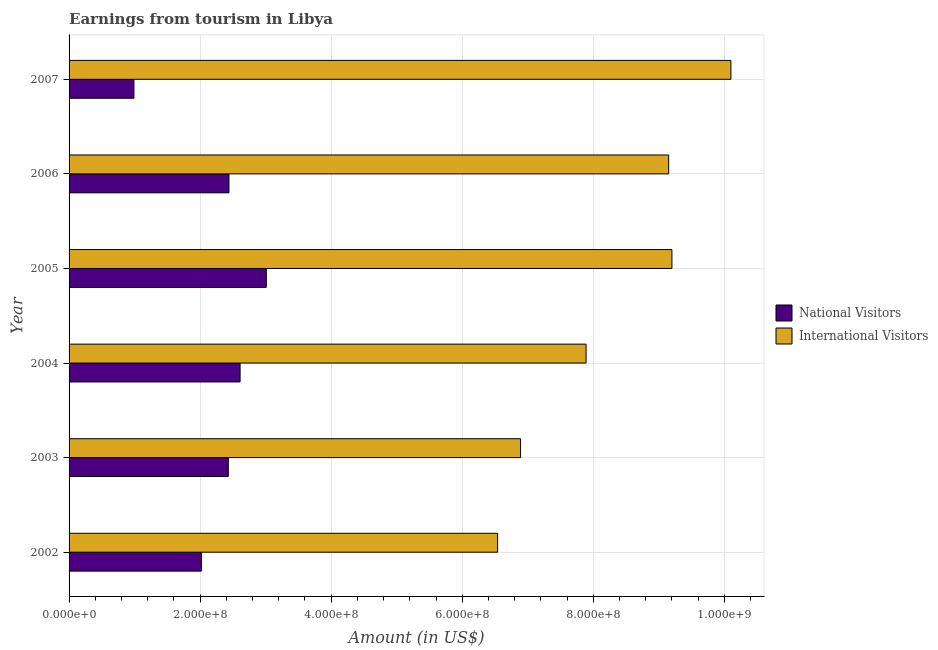How many different coloured bars are there?
Keep it short and to the point. 2. How many groups of bars are there?
Offer a terse response. 6. Are the number of bars on each tick of the Y-axis equal?
Your answer should be very brief. Yes. How many bars are there on the 3rd tick from the top?
Provide a short and direct response. 2. In how many cases, is the number of bars for a given year not equal to the number of legend labels?
Give a very brief answer. 0. What is the amount earned from international visitors in 2005?
Offer a very short reply. 9.20e+08. Across all years, what is the maximum amount earned from national visitors?
Your answer should be compact. 3.01e+08. Across all years, what is the minimum amount earned from national visitors?
Your answer should be very brief. 9.90e+07. In which year was the amount earned from international visitors maximum?
Keep it short and to the point. 2007. What is the total amount earned from international visitors in the graph?
Offer a terse response. 4.98e+09. What is the difference between the amount earned from international visitors in 2002 and that in 2007?
Make the answer very short. -3.56e+08. What is the difference between the amount earned from national visitors in 2004 and the amount earned from international visitors in 2005?
Ensure brevity in your answer.  -6.59e+08. What is the average amount earned from international visitors per year?
Provide a succinct answer. 8.30e+08. In the year 2002, what is the difference between the amount earned from international visitors and amount earned from national visitors?
Give a very brief answer. 4.52e+08. What is the ratio of the amount earned from international visitors in 2003 to that in 2007?
Keep it short and to the point. 0.68. Is the amount earned from national visitors in 2004 less than that in 2005?
Ensure brevity in your answer.  Yes. What is the difference between the highest and the second highest amount earned from international visitors?
Offer a terse response. 9.00e+07. What is the difference between the highest and the lowest amount earned from national visitors?
Offer a very short reply. 2.02e+08. In how many years, is the amount earned from international visitors greater than the average amount earned from international visitors taken over all years?
Your response must be concise. 3. What does the 2nd bar from the top in 2006 represents?
Your answer should be compact. National Visitors. What does the 2nd bar from the bottom in 2005 represents?
Your answer should be compact. International Visitors. How many bars are there?
Offer a very short reply. 12. Does the graph contain any zero values?
Offer a very short reply. No. Does the graph contain grids?
Offer a terse response. Yes. How many legend labels are there?
Your answer should be very brief. 2. What is the title of the graph?
Ensure brevity in your answer.  Earnings from tourism in Libya. Does "Urban Population" appear as one of the legend labels in the graph?
Your answer should be very brief. No. What is the label or title of the X-axis?
Offer a terse response. Amount (in US$). What is the label or title of the Y-axis?
Provide a short and direct response. Year. What is the Amount (in US$) in National Visitors in 2002?
Provide a short and direct response. 2.02e+08. What is the Amount (in US$) in International Visitors in 2002?
Your response must be concise. 6.54e+08. What is the Amount (in US$) of National Visitors in 2003?
Provide a succinct answer. 2.43e+08. What is the Amount (in US$) in International Visitors in 2003?
Give a very brief answer. 6.89e+08. What is the Amount (in US$) of National Visitors in 2004?
Give a very brief answer. 2.61e+08. What is the Amount (in US$) in International Visitors in 2004?
Make the answer very short. 7.89e+08. What is the Amount (in US$) in National Visitors in 2005?
Keep it short and to the point. 3.01e+08. What is the Amount (in US$) of International Visitors in 2005?
Keep it short and to the point. 9.20e+08. What is the Amount (in US$) in National Visitors in 2006?
Make the answer very short. 2.44e+08. What is the Amount (in US$) in International Visitors in 2006?
Offer a terse response. 9.15e+08. What is the Amount (in US$) in National Visitors in 2007?
Your response must be concise. 9.90e+07. What is the Amount (in US$) in International Visitors in 2007?
Give a very brief answer. 1.01e+09. Across all years, what is the maximum Amount (in US$) in National Visitors?
Keep it short and to the point. 3.01e+08. Across all years, what is the maximum Amount (in US$) in International Visitors?
Your answer should be very brief. 1.01e+09. Across all years, what is the minimum Amount (in US$) of National Visitors?
Offer a terse response. 9.90e+07. Across all years, what is the minimum Amount (in US$) of International Visitors?
Make the answer very short. 6.54e+08. What is the total Amount (in US$) in National Visitors in the graph?
Provide a short and direct response. 1.35e+09. What is the total Amount (in US$) of International Visitors in the graph?
Make the answer very short. 4.98e+09. What is the difference between the Amount (in US$) in National Visitors in 2002 and that in 2003?
Keep it short and to the point. -4.10e+07. What is the difference between the Amount (in US$) of International Visitors in 2002 and that in 2003?
Offer a terse response. -3.50e+07. What is the difference between the Amount (in US$) in National Visitors in 2002 and that in 2004?
Offer a very short reply. -5.90e+07. What is the difference between the Amount (in US$) in International Visitors in 2002 and that in 2004?
Your response must be concise. -1.35e+08. What is the difference between the Amount (in US$) in National Visitors in 2002 and that in 2005?
Offer a very short reply. -9.90e+07. What is the difference between the Amount (in US$) of International Visitors in 2002 and that in 2005?
Your answer should be very brief. -2.66e+08. What is the difference between the Amount (in US$) of National Visitors in 2002 and that in 2006?
Provide a succinct answer. -4.20e+07. What is the difference between the Amount (in US$) in International Visitors in 2002 and that in 2006?
Give a very brief answer. -2.61e+08. What is the difference between the Amount (in US$) in National Visitors in 2002 and that in 2007?
Your response must be concise. 1.03e+08. What is the difference between the Amount (in US$) in International Visitors in 2002 and that in 2007?
Ensure brevity in your answer.  -3.56e+08. What is the difference between the Amount (in US$) in National Visitors in 2003 and that in 2004?
Your answer should be compact. -1.80e+07. What is the difference between the Amount (in US$) in International Visitors in 2003 and that in 2004?
Keep it short and to the point. -1.00e+08. What is the difference between the Amount (in US$) of National Visitors in 2003 and that in 2005?
Provide a succinct answer. -5.80e+07. What is the difference between the Amount (in US$) in International Visitors in 2003 and that in 2005?
Your answer should be very brief. -2.31e+08. What is the difference between the Amount (in US$) of International Visitors in 2003 and that in 2006?
Make the answer very short. -2.26e+08. What is the difference between the Amount (in US$) in National Visitors in 2003 and that in 2007?
Offer a terse response. 1.44e+08. What is the difference between the Amount (in US$) in International Visitors in 2003 and that in 2007?
Provide a succinct answer. -3.21e+08. What is the difference between the Amount (in US$) of National Visitors in 2004 and that in 2005?
Make the answer very short. -4.00e+07. What is the difference between the Amount (in US$) in International Visitors in 2004 and that in 2005?
Your response must be concise. -1.31e+08. What is the difference between the Amount (in US$) in National Visitors in 2004 and that in 2006?
Your answer should be very brief. 1.70e+07. What is the difference between the Amount (in US$) in International Visitors in 2004 and that in 2006?
Give a very brief answer. -1.26e+08. What is the difference between the Amount (in US$) of National Visitors in 2004 and that in 2007?
Offer a very short reply. 1.62e+08. What is the difference between the Amount (in US$) of International Visitors in 2004 and that in 2007?
Make the answer very short. -2.21e+08. What is the difference between the Amount (in US$) of National Visitors in 2005 and that in 2006?
Provide a succinct answer. 5.70e+07. What is the difference between the Amount (in US$) of National Visitors in 2005 and that in 2007?
Your answer should be compact. 2.02e+08. What is the difference between the Amount (in US$) in International Visitors in 2005 and that in 2007?
Your answer should be compact. -9.00e+07. What is the difference between the Amount (in US$) in National Visitors in 2006 and that in 2007?
Your response must be concise. 1.45e+08. What is the difference between the Amount (in US$) in International Visitors in 2006 and that in 2007?
Your answer should be compact. -9.50e+07. What is the difference between the Amount (in US$) in National Visitors in 2002 and the Amount (in US$) in International Visitors in 2003?
Your answer should be very brief. -4.87e+08. What is the difference between the Amount (in US$) in National Visitors in 2002 and the Amount (in US$) in International Visitors in 2004?
Your answer should be compact. -5.87e+08. What is the difference between the Amount (in US$) of National Visitors in 2002 and the Amount (in US$) of International Visitors in 2005?
Offer a very short reply. -7.18e+08. What is the difference between the Amount (in US$) in National Visitors in 2002 and the Amount (in US$) in International Visitors in 2006?
Offer a very short reply. -7.13e+08. What is the difference between the Amount (in US$) of National Visitors in 2002 and the Amount (in US$) of International Visitors in 2007?
Give a very brief answer. -8.08e+08. What is the difference between the Amount (in US$) in National Visitors in 2003 and the Amount (in US$) in International Visitors in 2004?
Offer a terse response. -5.46e+08. What is the difference between the Amount (in US$) of National Visitors in 2003 and the Amount (in US$) of International Visitors in 2005?
Your answer should be compact. -6.77e+08. What is the difference between the Amount (in US$) of National Visitors in 2003 and the Amount (in US$) of International Visitors in 2006?
Your response must be concise. -6.72e+08. What is the difference between the Amount (in US$) in National Visitors in 2003 and the Amount (in US$) in International Visitors in 2007?
Your response must be concise. -7.67e+08. What is the difference between the Amount (in US$) in National Visitors in 2004 and the Amount (in US$) in International Visitors in 2005?
Offer a terse response. -6.59e+08. What is the difference between the Amount (in US$) of National Visitors in 2004 and the Amount (in US$) of International Visitors in 2006?
Provide a short and direct response. -6.54e+08. What is the difference between the Amount (in US$) of National Visitors in 2004 and the Amount (in US$) of International Visitors in 2007?
Provide a succinct answer. -7.49e+08. What is the difference between the Amount (in US$) of National Visitors in 2005 and the Amount (in US$) of International Visitors in 2006?
Provide a succinct answer. -6.14e+08. What is the difference between the Amount (in US$) of National Visitors in 2005 and the Amount (in US$) of International Visitors in 2007?
Your answer should be compact. -7.09e+08. What is the difference between the Amount (in US$) of National Visitors in 2006 and the Amount (in US$) of International Visitors in 2007?
Offer a terse response. -7.66e+08. What is the average Amount (in US$) in National Visitors per year?
Ensure brevity in your answer.  2.25e+08. What is the average Amount (in US$) of International Visitors per year?
Provide a succinct answer. 8.30e+08. In the year 2002, what is the difference between the Amount (in US$) in National Visitors and Amount (in US$) in International Visitors?
Provide a succinct answer. -4.52e+08. In the year 2003, what is the difference between the Amount (in US$) of National Visitors and Amount (in US$) of International Visitors?
Give a very brief answer. -4.46e+08. In the year 2004, what is the difference between the Amount (in US$) in National Visitors and Amount (in US$) in International Visitors?
Your answer should be compact. -5.28e+08. In the year 2005, what is the difference between the Amount (in US$) of National Visitors and Amount (in US$) of International Visitors?
Your answer should be very brief. -6.19e+08. In the year 2006, what is the difference between the Amount (in US$) of National Visitors and Amount (in US$) of International Visitors?
Ensure brevity in your answer.  -6.71e+08. In the year 2007, what is the difference between the Amount (in US$) in National Visitors and Amount (in US$) in International Visitors?
Ensure brevity in your answer.  -9.11e+08. What is the ratio of the Amount (in US$) in National Visitors in 2002 to that in 2003?
Provide a short and direct response. 0.83. What is the ratio of the Amount (in US$) in International Visitors in 2002 to that in 2003?
Your answer should be very brief. 0.95. What is the ratio of the Amount (in US$) in National Visitors in 2002 to that in 2004?
Keep it short and to the point. 0.77. What is the ratio of the Amount (in US$) in International Visitors in 2002 to that in 2004?
Provide a succinct answer. 0.83. What is the ratio of the Amount (in US$) in National Visitors in 2002 to that in 2005?
Ensure brevity in your answer.  0.67. What is the ratio of the Amount (in US$) in International Visitors in 2002 to that in 2005?
Your answer should be compact. 0.71. What is the ratio of the Amount (in US$) in National Visitors in 2002 to that in 2006?
Provide a succinct answer. 0.83. What is the ratio of the Amount (in US$) in International Visitors in 2002 to that in 2006?
Offer a very short reply. 0.71. What is the ratio of the Amount (in US$) in National Visitors in 2002 to that in 2007?
Offer a very short reply. 2.04. What is the ratio of the Amount (in US$) of International Visitors in 2002 to that in 2007?
Give a very brief answer. 0.65. What is the ratio of the Amount (in US$) in International Visitors in 2003 to that in 2004?
Provide a succinct answer. 0.87. What is the ratio of the Amount (in US$) in National Visitors in 2003 to that in 2005?
Offer a terse response. 0.81. What is the ratio of the Amount (in US$) of International Visitors in 2003 to that in 2005?
Keep it short and to the point. 0.75. What is the ratio of the Amount (in US$) of National Visitors in 2003 to that in 2006?
Your response must be concise. 1. What is the ratio of the Amount (in US$) of International Visitors in 2003 to that in 2006?
Your answer should be compact. 0.75. What is the ratio of the Amount (in US$) in National Visitors in 2003 to that in 2007?
Your answer should be compact. 2.45. What is the ratio of the Amount (in US$) in International Visitors in 2003 to that in 2007?
Give a very brief answer. 0.68. What is the ratio of the Amount (in US$) of National Visitors in 2004 to that in 2005?
Your response must be concise. 0.87. What is the ratio of the Amount (in US$) in International Visitors in 2004 to that in 2005?
Provide a short and direct response. 0.86. What is the ratio of the Amount (in US$) in National Visitors in 2004 to that in 2006?
Provide a short and direct response. 1.07. What is the ratio of the Amount (in US$) of International Visitors in 2004 to that in 2006?
Provide a succinct answer. 0.86. What is the ratio of the Amount (in US$) in National Visitors in 2004 to that in 2007?
Your answer should be compact. 2.64. What is the ratio of the Amount (in US$) of International Visitors in 2004 to that in 2007?
Provide a short and direct response. 0.78. What is the ratio of the Amount (in US$) in National Visitors in 2005 to that in 2006?
Ensure brevity in your answer.  1.23. What is the ratio of the Amount (in US$) of National Visitors in 2005 to that in 2007?
Your answer should be very brief. 3.04. What is the ratio of the Amount (in US$) in International Visitors in 2005 to that in 2007?
Provide a short and direct response. 0.91. What is the ratio of the Amount (in US$) of National Visitors in 2006 to that in 2007?
Make the answer very short. 2.46. What is the ratio of the Amount (in US$) of International Visitors in 2006 to that in 2007?
Offer a very short reply. 0.91. What is the difference between the highest and the second highest Amount (in US$) of National Visitors?
Your response must be concise. 4.00e+07. What is the difference between the highest and the second highest Amount (in US$) of International Visitors?
Keep it short and to the point. 9.00e+07. What is the difference between the highest and the lowest Amount (in US$) of National Visitors?
Keep it short and to the point. 2.02e+08. What is the difference between the highest and the lowest Amount (in US$) in International Visitors?
Your answer should be compact. 3.56e+08. 